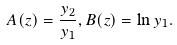Convert formula to latex. <formula><loc_0><loc_0><loc_500><loc_500>A ( z ) = \frac { y _ { 2 } } { y _ { 1 } } , B ( z ) = \ln y _ { 1 } .</formula> 